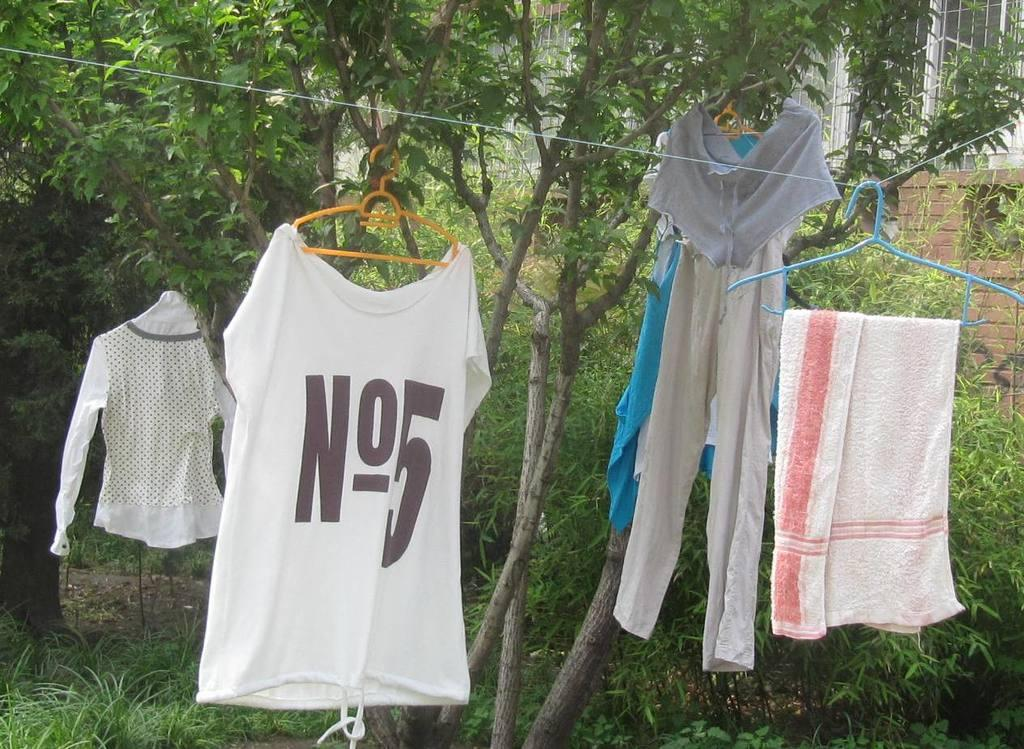<image>
Write a terse but informative summary of the picture. A white No 5 shirt hangs on a rope by some trees. 